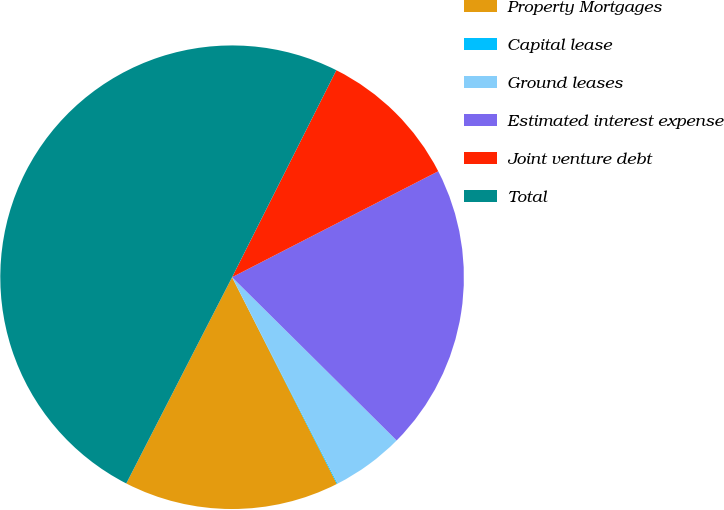<chart> <loc_0><loc_0><loc_500><loc_500><pie_chart><fcel>Property Mortgages<fcel>Capital lease<fcel>Ground leases<fcel>Estimated interest expense<fcel>Joint venture debt<fcel>Total<nl><fcel>15.01%<fcel>0.06%<fcel>5.04%<fcel>19.99%<fcel>10.02%<fcel>49.88%<nl></chart> 